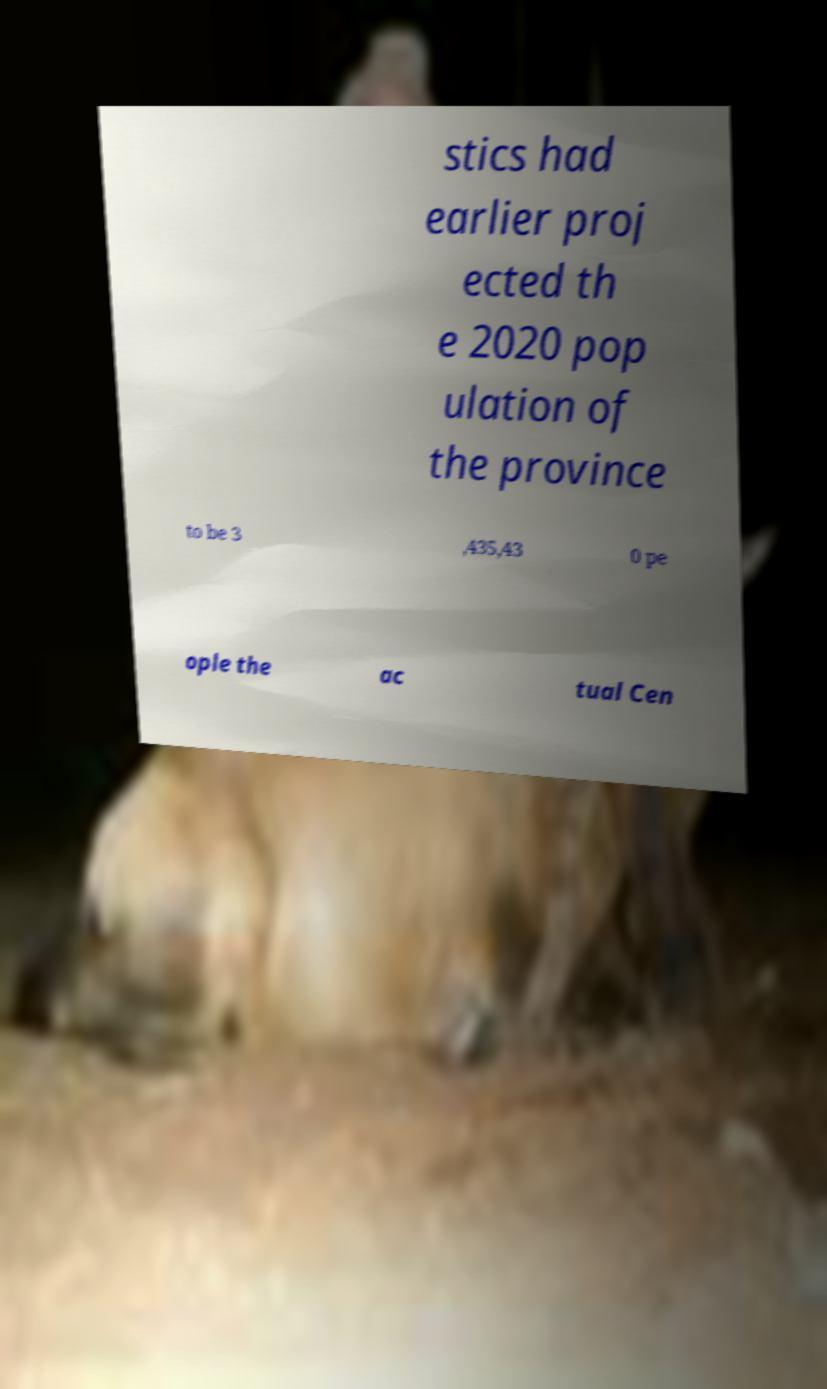Can you read and provide the text displayed in the image?This photo seems to have some interesting text. Can you extract and type it out for me? stics had earlier proj ected th e 2020 pop ulation of the province to be 3 ,435,43 0 pe ople the ac tual Cen 